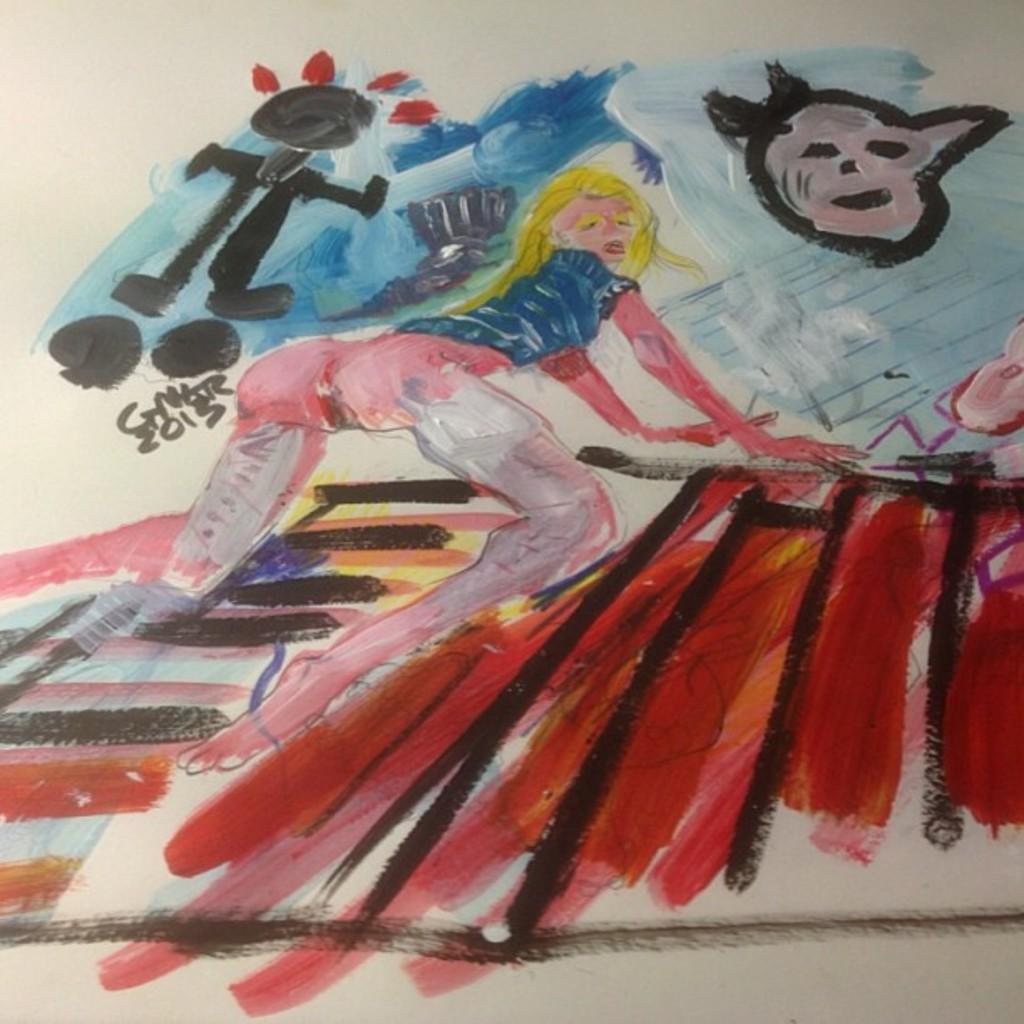What is depicted on the paper in the image? There is a drawing on a paper in the image. What can be observed about the drawing in terms of color? The drawing uses different colors. What type of animal can be heard making noise in the image? There is no animal present in the image, and therefore no sound can be heard. 